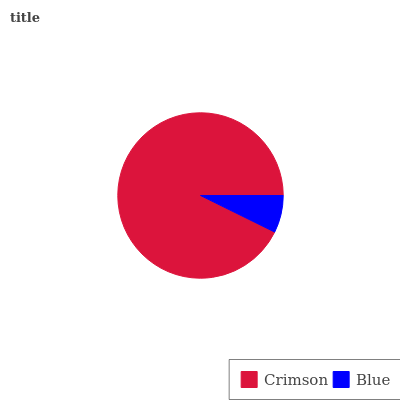Is Blue the minimum?
Answer yes or no. Yes. Is Crimson the maximum?
Answer yes or no. Yes. Is Blue the maximum?
Answer yes or no. No. Is Crimson greater than Blue?
Answer yes or no. Yes. Is Blue less than Crimson?
Answer yes or no. Yes. Is Blue greater than Crimson?
Answer yes or no. No. Is Crimson less than Blue?
Answer yes or no. No. Is Crimson the high median?
Answer yes or no. Yes. Is Blue the low median?
Answer yes or no. Yes. Is Blue the high median?
Answer yes or no. No. Is Crimson the low median?
Answer yes or no. No. 